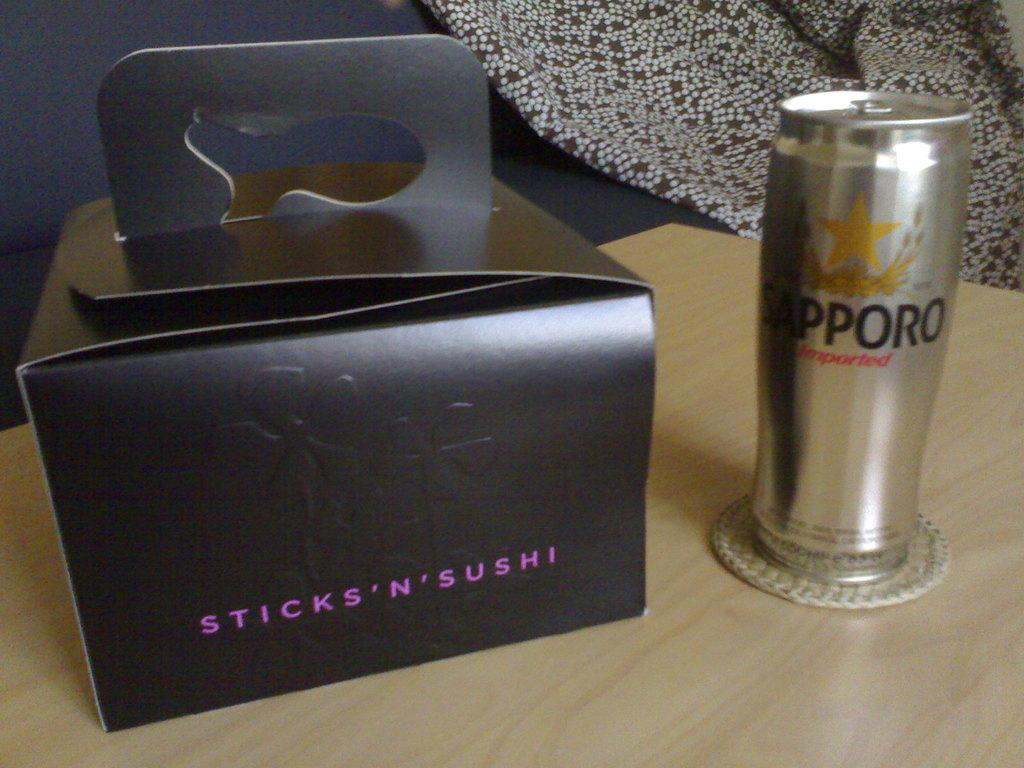<image>
Share a concise interpretation of the image provided. Stick N Sushi on the table next to a can of beer. 